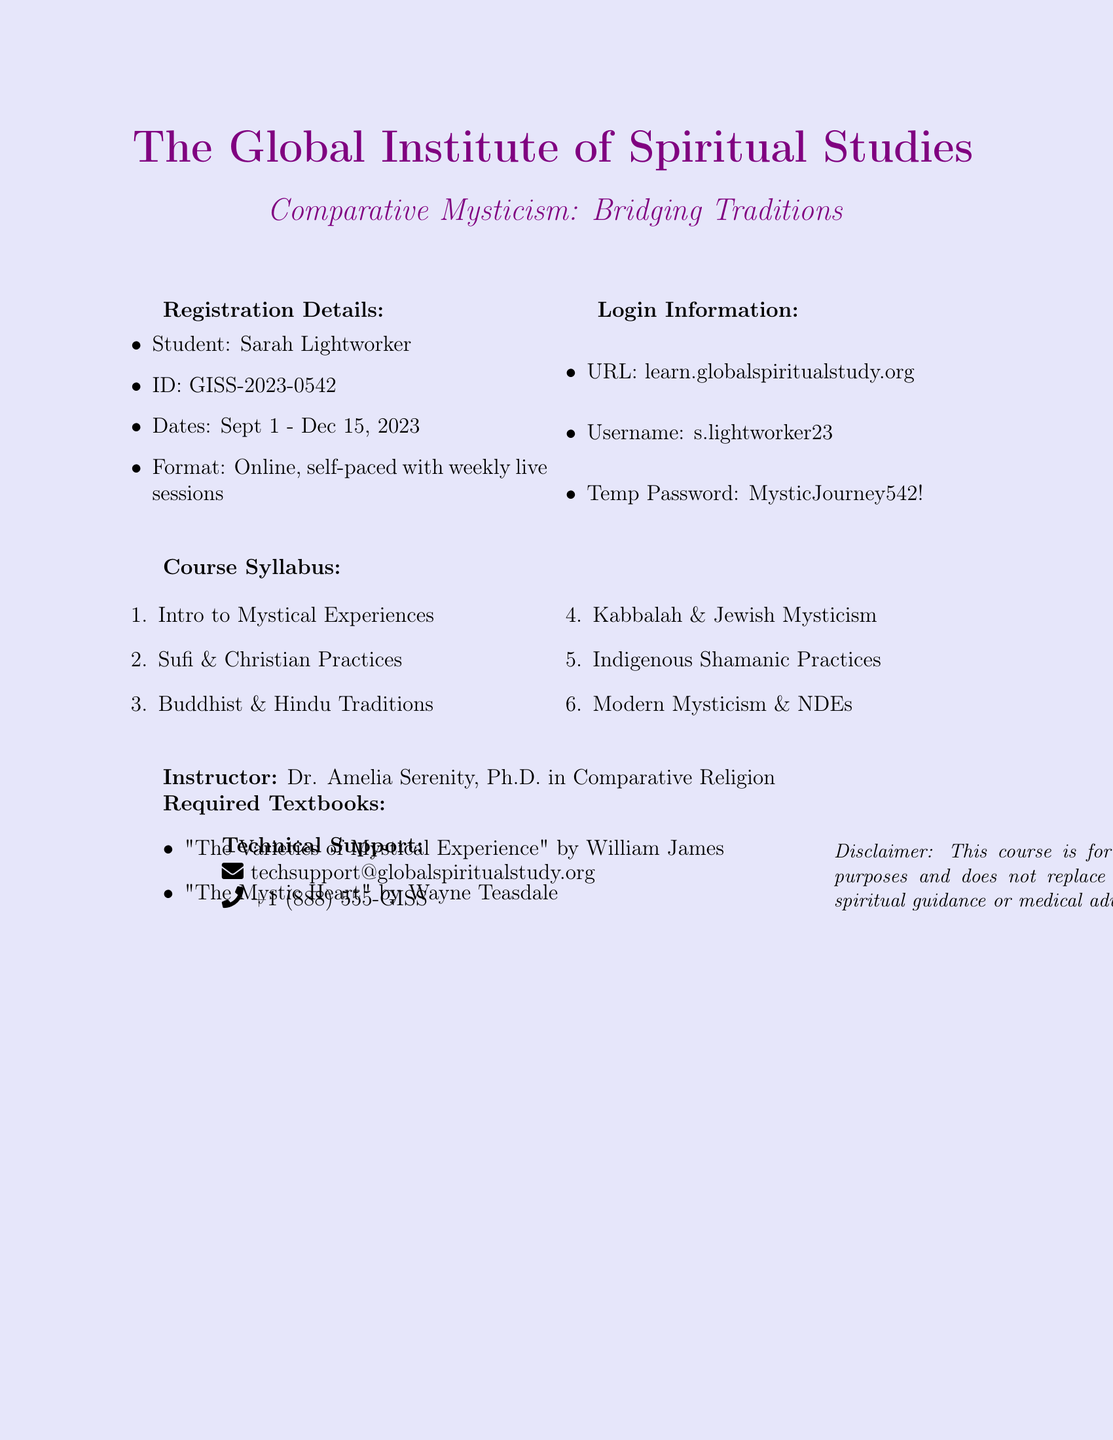What is the course title? The title of the course is stated as "Comparative Mysticism: Bridging Traditions."
Answer: Comparative Mysticism: Bridging Traditions Who is the instructor? The document specifies the instructor's name and qualifications.
Answer: Dr. Amelia Serenity What is the student ID? The ID assigned to the student is noted in the registration details.
Answer: GISS-2023-0542 What are the course dates? The starting and ending dates of the course are provided in the document.
Answer: Sept 1 - Dec 15, 2023 What is the temporary password? The login information includes a temporary password for accessing the course.
Answer: MysticJourney542! How many weeks are the live sessions held? The course format includes live sessions held weekly throughout the duration of the course.
Answer: Weekly What is one required textbook? The list of required textbooks includes prominent works on mysticism.
Answer: "The Varieties of Mystical Experience" What type of course is this? The document mentions the format and nature of the course.
Answer: Online, self-paced What is the technical support email? The document includes a specific email address for technical support inquiries.
Answer: techsupport@globalspiritualstudy.org 